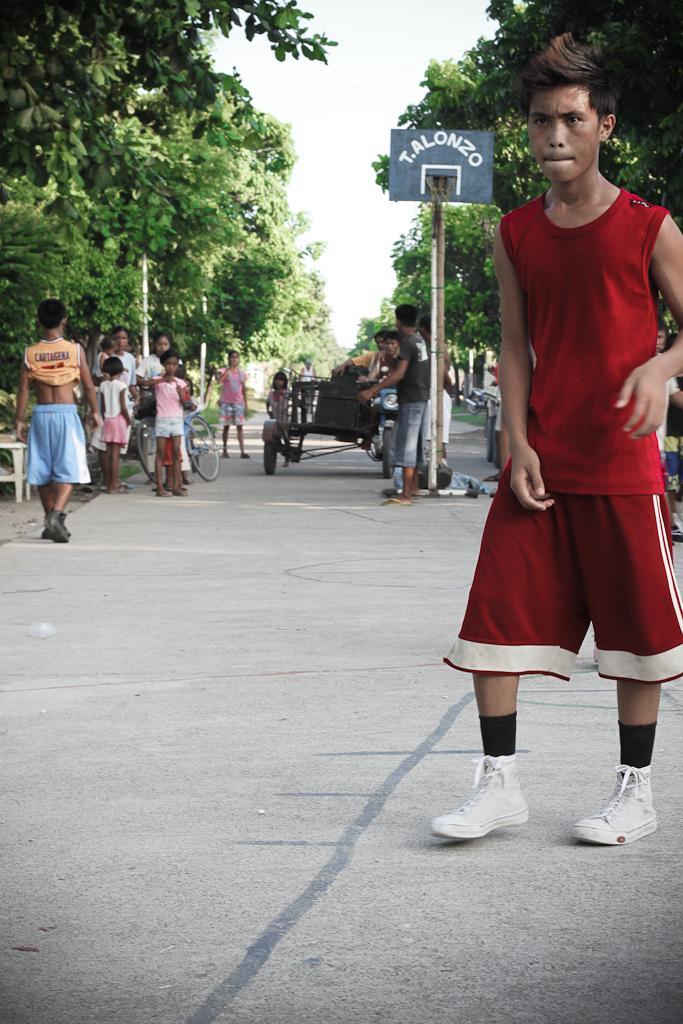Describe this image in one or two sentences. In this image I can see a person wearing red and white colored dress is standing on the road. In the background I can see few other persons standing on the road, a vehicles on the road, a person holding a bicycle, few trees on both sides of the road, few poles and the sky. 